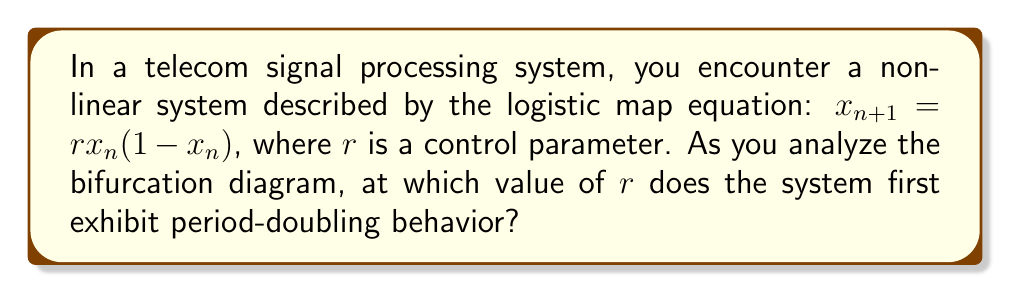Could you help me with this problem? To analyze the bifurcation diagram of this nonlinear system, we need to follow these steps:

1) The logistic map equation $x_{n+1} = rx_n(1-x_n)$ is a classic example of a nonlinear system that exhibits chaos.

2) In the bifurcation diagram, we plot the long-term behavior of $x$ against different values of $r$.

3) For $0 < r < 1$, the system has a single fixed point at $x = 0$.

4) As $r$ increases beyond 1, the fixed point moves to $x = 1 - \frac{1}{r}$.

5) The period-doubling behavior begins when this fixed point becomes unstable. This occurs when:

   $$\left|\frac{d}{dx}(rx(1-x))\right|_{x=1-\frac{1}{r}} > 1$$

6) Solving this inequality:

   $$\left|r(1-2x)\right|_{x=1-\frac{1}{r}} > 1$$
   $$\left|r(1-2(1-\frac{1}{r}))\right| > 1$$
   $$\left|r(-1+\frac{2}{r})\right| > 1$$
   $$|-r+2| > 1$$

7) This inequality is satisfied when $r > 3$.

Therefore, the system first exhibits period-doubling behavior when $r$ exceeds 3.
Answer: $r = 3$ 